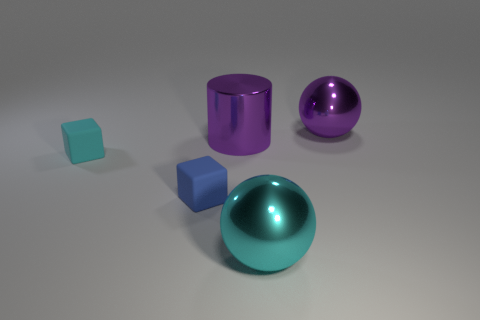If the large purple ball was removed, which color would dominate the image? If the large purple ball was removed, the cyan color from the smaller cube would become the most dominating color in the image as it's the brightest and most distinct hue compared to the remaining muted colors. 